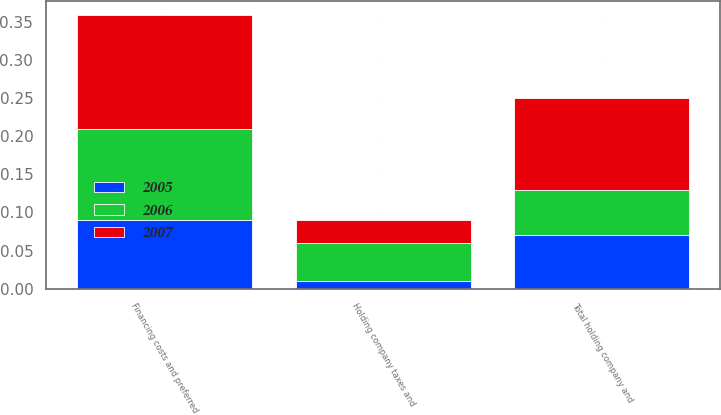Convert chart to OTSL. <chart><loc_0><loc_0><loc_500><loc_500><stacked_bar_chart><ecel><fcel>Financing costs and preferred<fcel>Holding company taxes and<fcel>Total holding company and<nl><fcel>2007<fcel>0.15<fcel>0.03<fcel>0.12<nl><fcel>2006<fcel>0.12<fcel>0.05<fcel>0.06<nl><fcel>2005<fcel>0.09<fcel>0.01<fcel>0.07<nl></chart> 